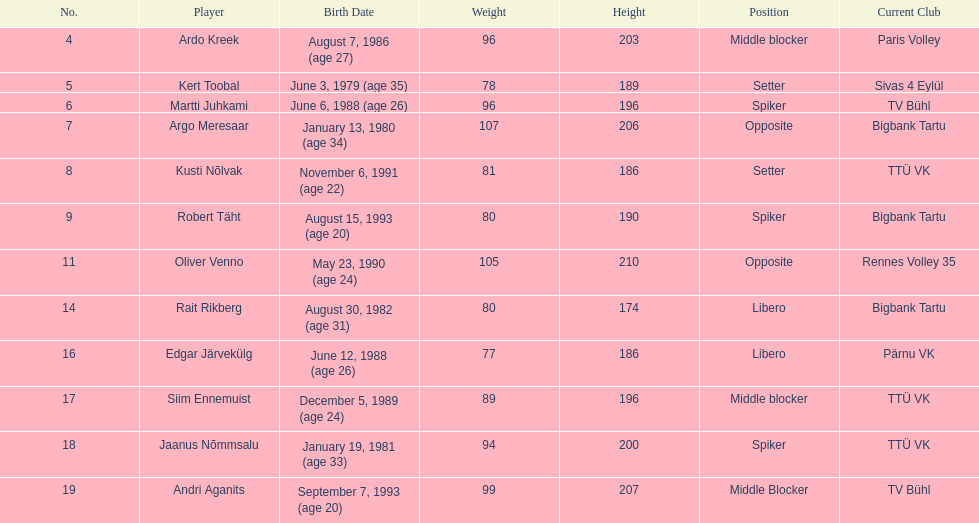Can you parse all the data within this table? {'header': ['No.', 'Player', 'Birth Date', 'Weight', 'Height', 'Position', 'Current Club'], 'rows': [['4', 'Ardo Kreek', 'August 7, 1986 (age\xa027)', '96', '203', 'Middle blocker', 'Paris Volley'], ['5', 'Kert Toobal', 'June 3, 1979 (age\xa035)', '78', '189', 'Setter', 'Sivas 4 Eylül'], ['6', 'Martti Juhkami', 'June 6, 1988 (age\xa026)', '96', '196', 'Spiker', 'TV Bühl'], ['7', 'Argo Meresaar', 'January 13, 1980 (age\xa034)', '107', '206', 'Opposite', 'Bigbank Tartu'], ['8', 'Kusti Nõlvak', 'November 6, 1991 (age\xa022)', '81', '186', 'Setter', 'TTÜ VK'], ['9', 'Robert Täht', 'August 15, 1993 (age\xa020)', '80', '190', 'Spiker', 'Bigbank Tartu'], ['11', 'Oliver Venno', 'May 23, 1990 (age\xa024)', '105', '210', 'Opposite', 'Rennes Volley 35'], ['14', 'Rait Rikberg', 'August 30, 1982 (age\xa031)', '80', '174', 'Libero', 'Bigbank Tartu'], ['16', 'Edgar Järvekülg', 'June 12, 1988 (age\xa026)', '77', '186', 'Libero', 'Pärnu VK'], ['17', 'Siim Ennemuist', 'December 5, 1989 (age\xa024)', '89', '196', 'Middle blocker', 'TTÜ VK'], ['18', 'Jaanus Nõmmsalu', 'January 19, 1981 (age\xa033)', '94', '200', 'Spiker', 'TTÜ VK'], ['19', 'Andri Aganits', 'September 7, 1993 (age\xa020)', '99', '207', 'Middle Blocker', 'TV Bühl']]} Can you determine the difference in height between oliver venno and rait rikberg? 36. 